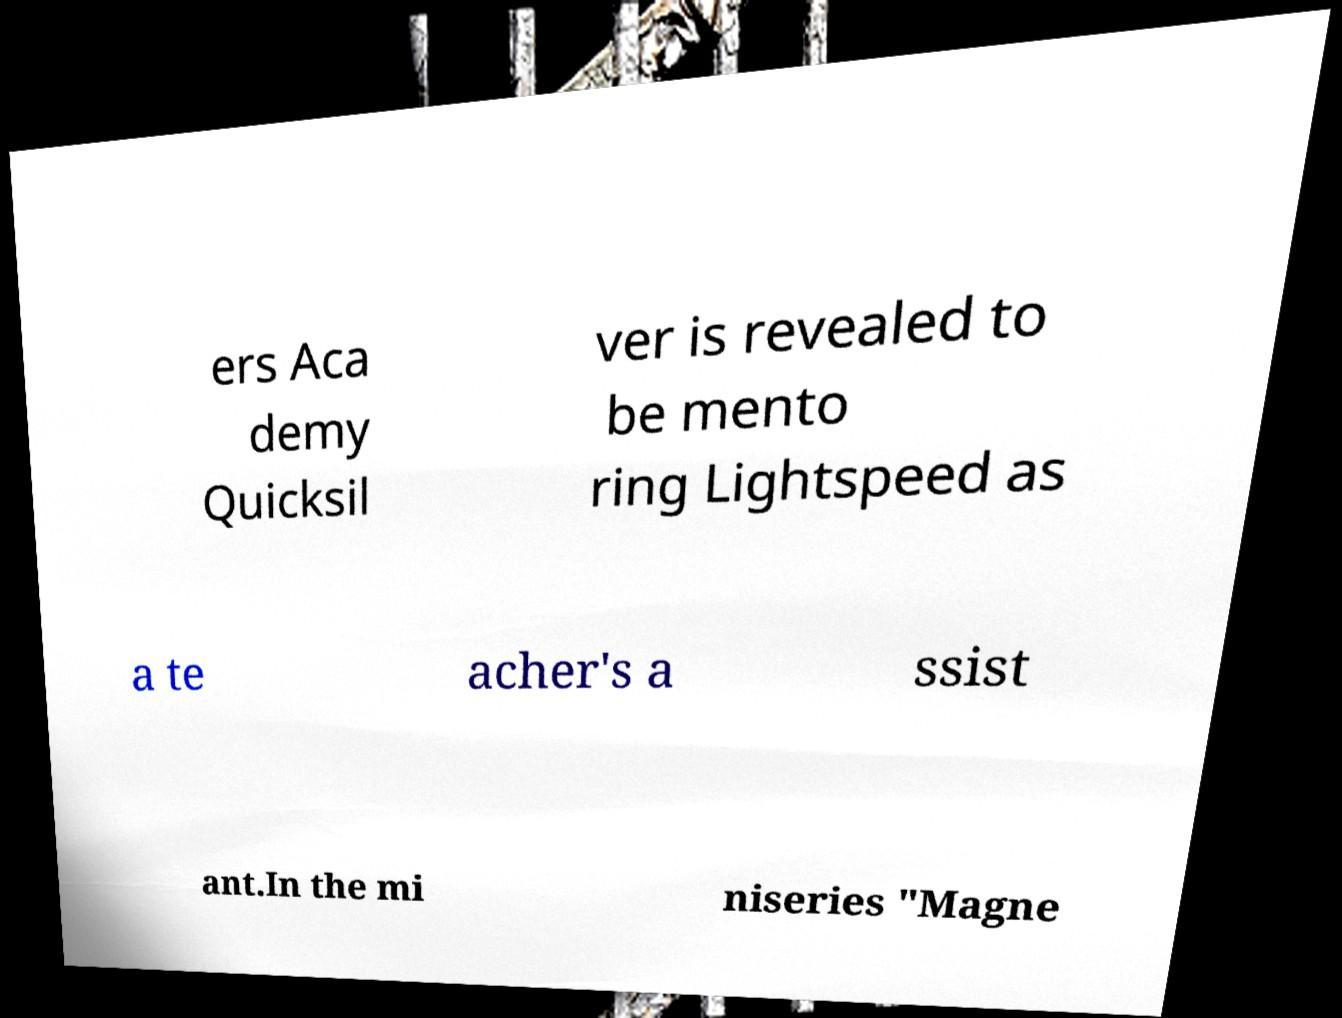Could you assist in decoding the text presented in this image and type it out clearly? ers Aca demy Quicksil ver is revealed to be mento ring Lightspeed as a te acher's a ssist ant.In the mi niseries "Magne 